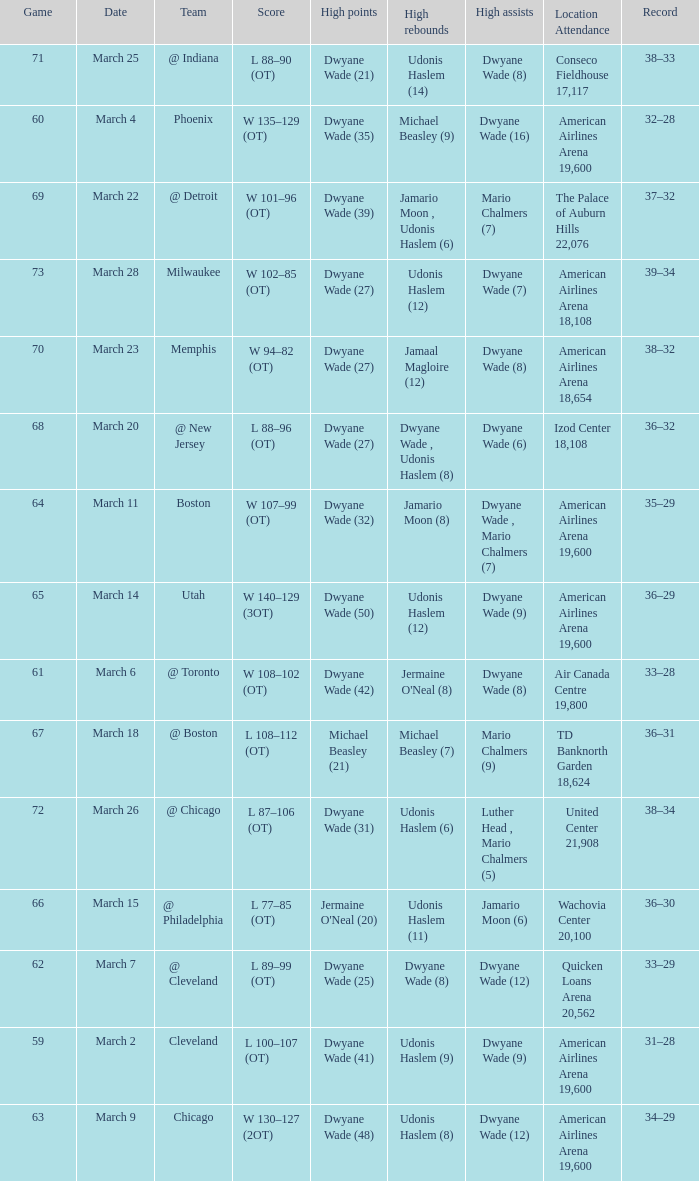Who had the high point total against cleveland? Dwyane Wade (41). 